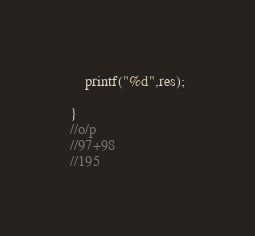Convert code to text. <code><loc_0><loc_0><loc_500><loc_500><_C_>    printf("%d",res);
    
}
//o/p
//97+98
//195
</code> 